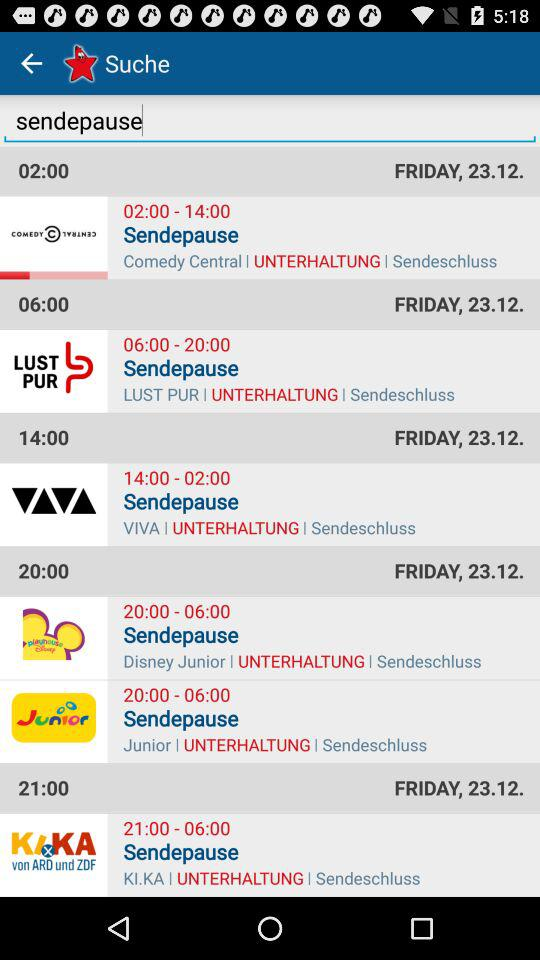What is the time for "LUST PUR"? The time is 06:00–20:00. 